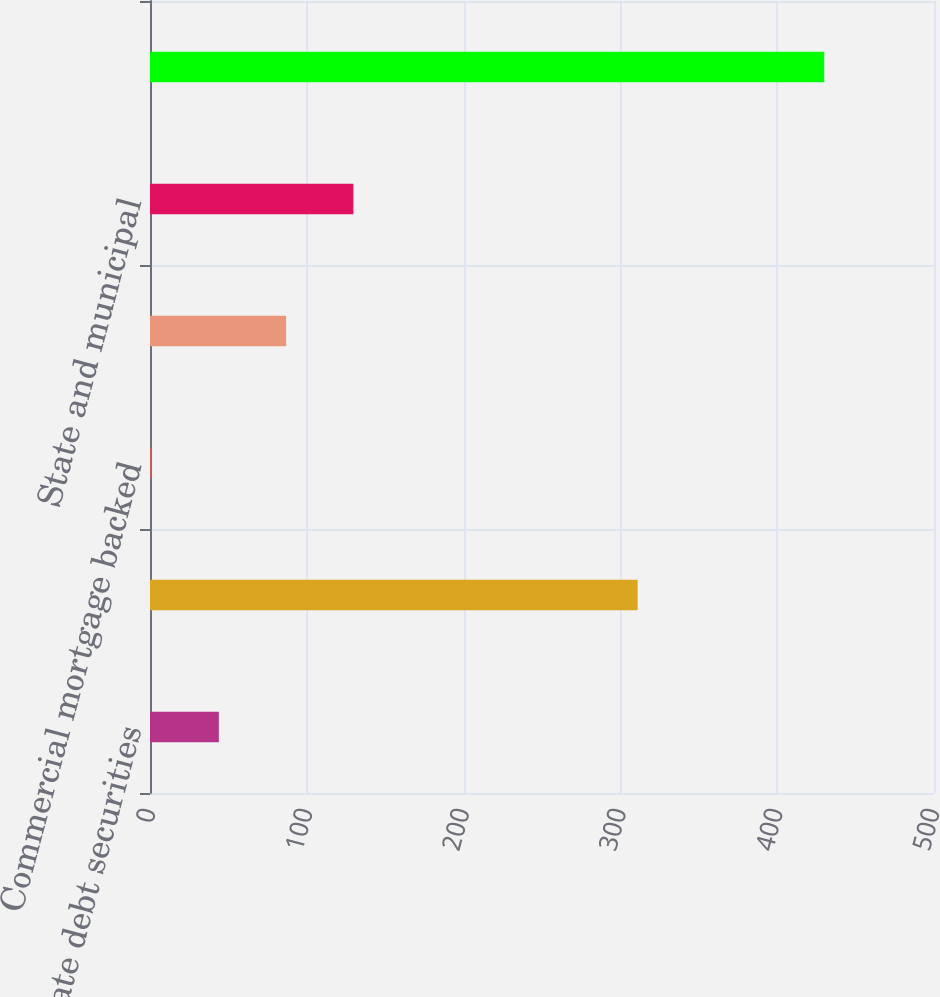Convert chart to OTSL. <chart><loc_0><loc_0><loc_500><loc_500><bar_chart><fcel>Corporate debt securities<fcel>Residential mortgage backed<fcel>Commercial mortgage backed<fcel>Asset backed securities<fcel>State and municipal<fcel>Total<nl><fcel>43.9<fcel>311<fcel>1<fcel>86.8<fcel>129.7<fcel>430<nl></chart> 